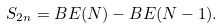Convert formula to latex. <formula><loc_0><loc_0><loc_500><loc_500>S _ { 2 n } = B E ( N ) - B E ( N - 1 ) .</formula> 